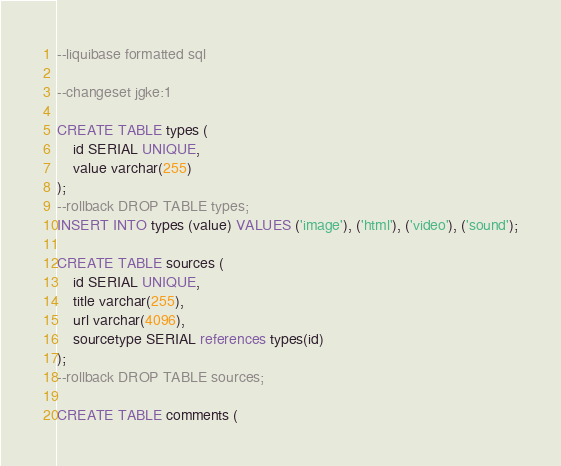Convert code to text. <code><loc_0><loc_0><loc_500><loc_500><_SQL_>--liquibase formatted sql

--changeset jgke:1

CREATE TABLE types (
    id SERIAL UNIQUE,
    value varchar(255)
);
--rollback DROP TABLE types;
INSERT INTO types (value) VALUES ('image'), ('html'), ('video'), ('sound');

CREATE TABLE sources (
    id SERIAL UNIQUE,
    title varchar(255),
    url varchar(4096),
    sourcetype SERIAL references types(id)
);
--rollback DROP TABLE sources;

CREATE TABLE comments (</code> 